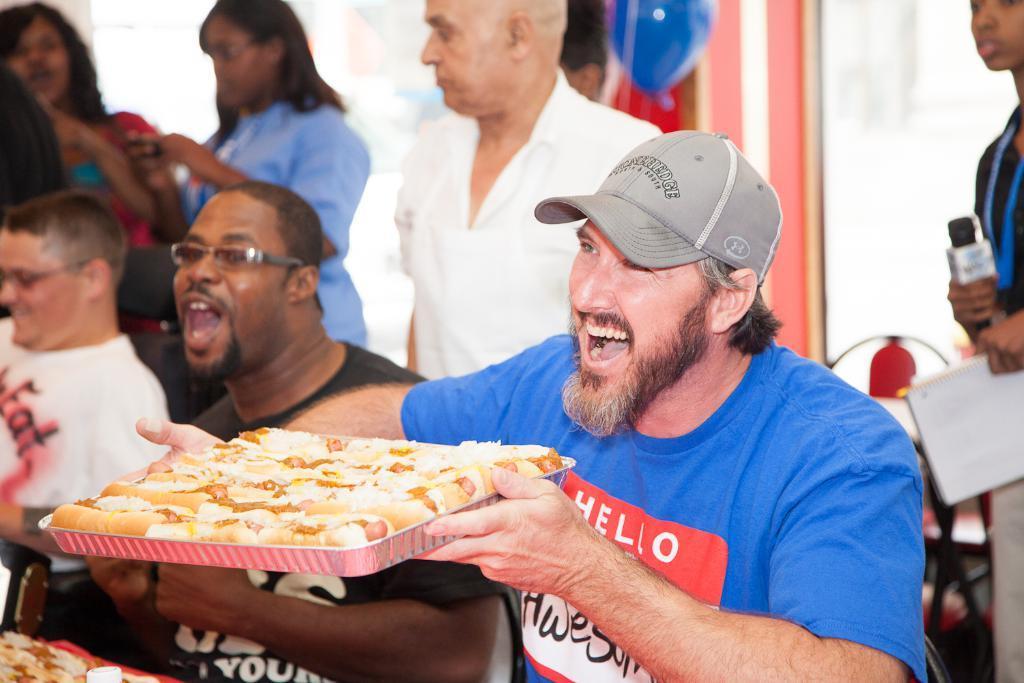Can you describe this image briefly? Here I can see a man wearing blue color t-shirt, cap on the head, holding a pizza in the hands and smiling. At the back of him I can see some more people. Few are sitting, few are standing. On the right side there is a person standing, holding a mike and a book in the hands. The background is blurred. 